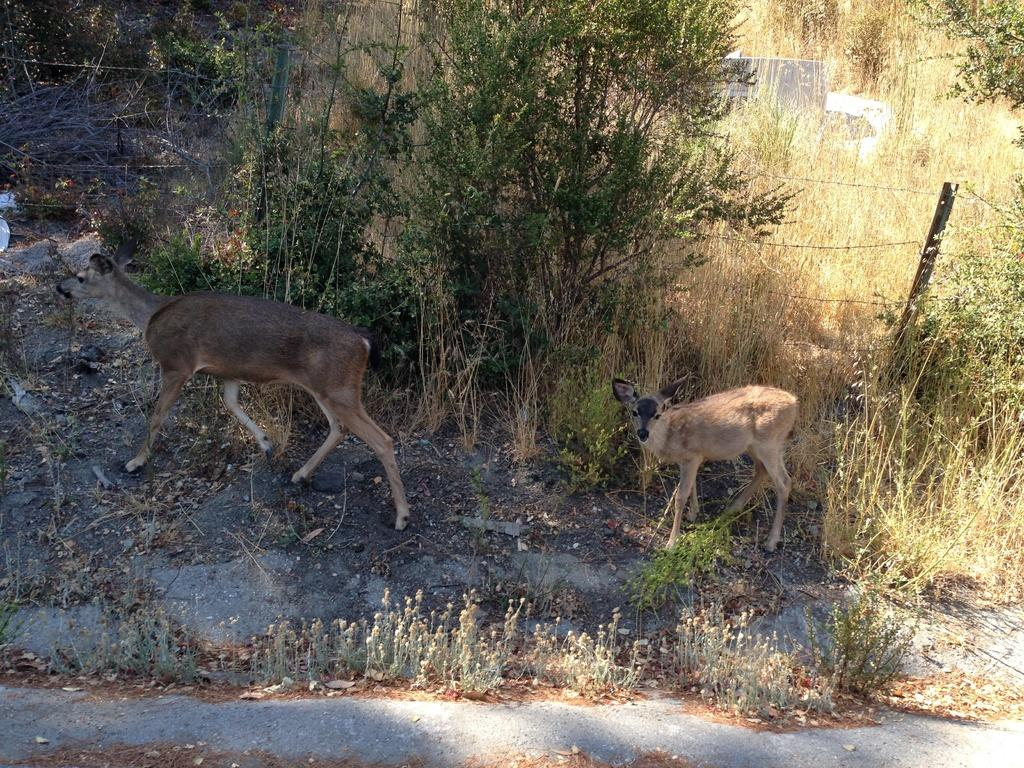What animals can be seen in the image? There are two deer in the image. What type of vegetation is visible in the background of the image? There are plants and trees in the background of the image. What can be seen in the background of the image that might indicate a boundary or border? There is a boundary in the background of the image. What type of meat is being cooked on the trail in the image? There is no trail or any indication of cooking in the image; it features two deer and a background with plants, trees, and a boundary. How many bears can be seen interacting with the deer in the image? There are no bears present in the image. 